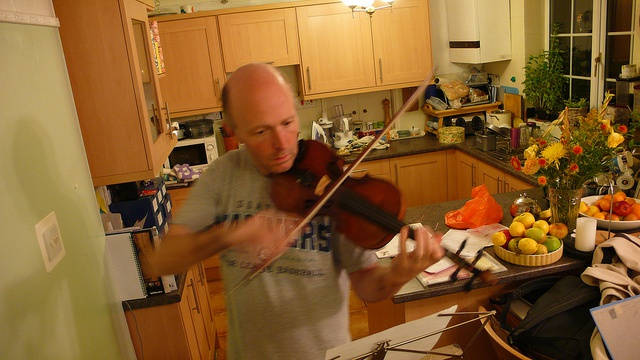Describe the objects in this image and their specific colors. I can see people in tan, olive, maroon, brown, and gray tones, refrigerator in tan and olive tones, backpack in tan, black, maroon, and olive tones, potted plant in tan, black, maroon, and olive tones, and potted plant in tan, black, olive, and darkgreen tones in this image. 